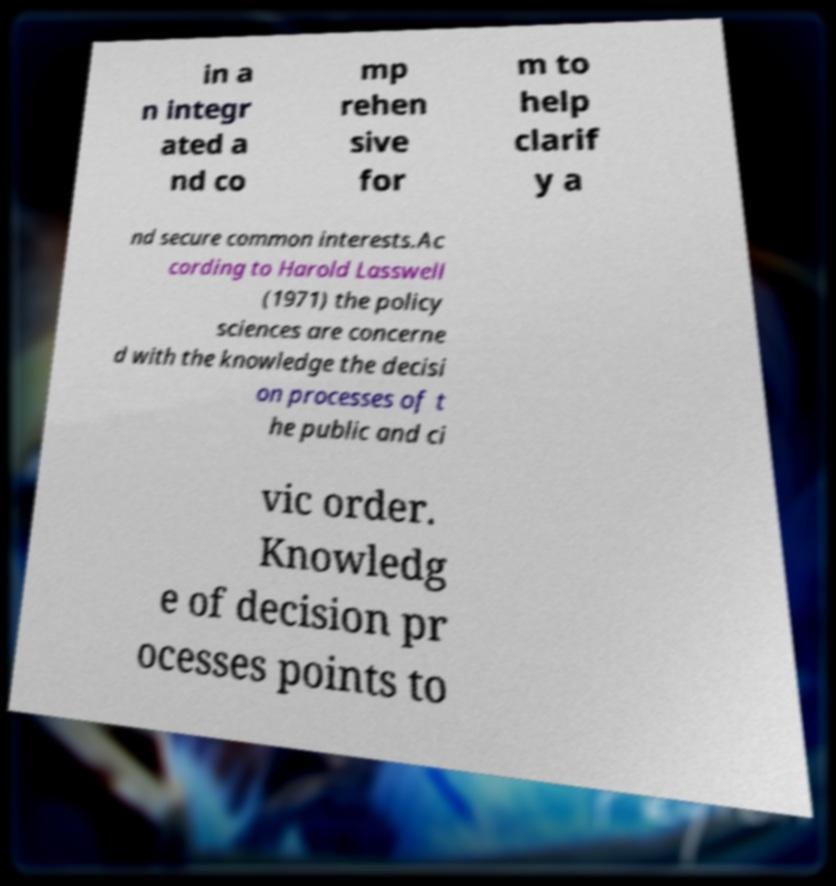Could you assist in decoding the text presented in this image and type it out clearly? in a n integr ated a nd co mp rehen sive for m to help clarif y a nd secure common interests.Ac cording to Harold Lasswell (1971) the policy sciences are concerne d with the knowledge the decisi on processes of t he public and ci vic order. Knowledg e of decision pr ocesses points to 